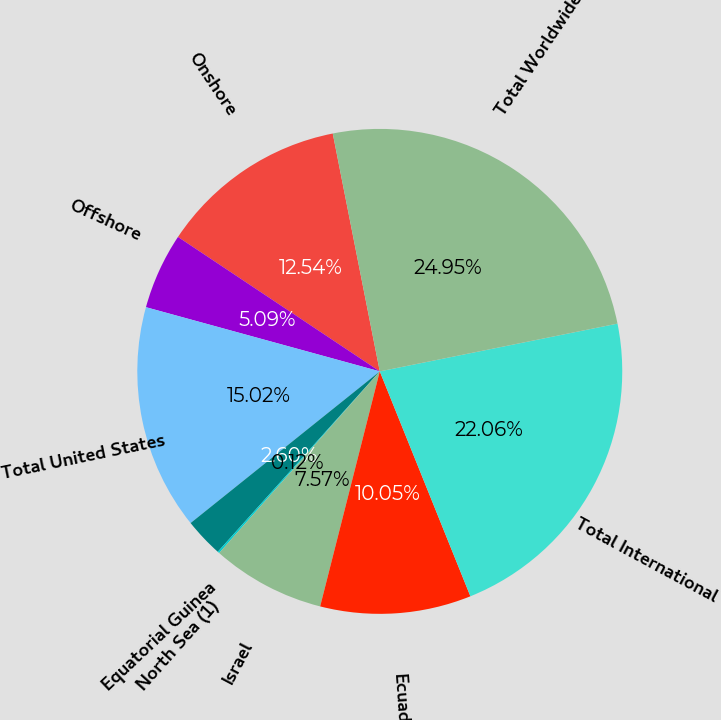Convert chart. <chart><loc_0><loc_0><loc_500><loc_500><pie_chart><fcel>Onshore<fcel>Offshore<fcel>Total United States<fcel>Equatorial Guinea<fcel>North Sea (1)<fcel>Israel<fcel>Ecuador<fcel>Total International<fcel>Total Worldwide (3)<nl><fcel>12.54%<fcel>5.09%<fcel>15.02%<fcel>2.6%<fcel>0.12%<fcel>7.57%<fcel>10.05%<fcel>22.06%<fcel>24.95%<nl></chart> 